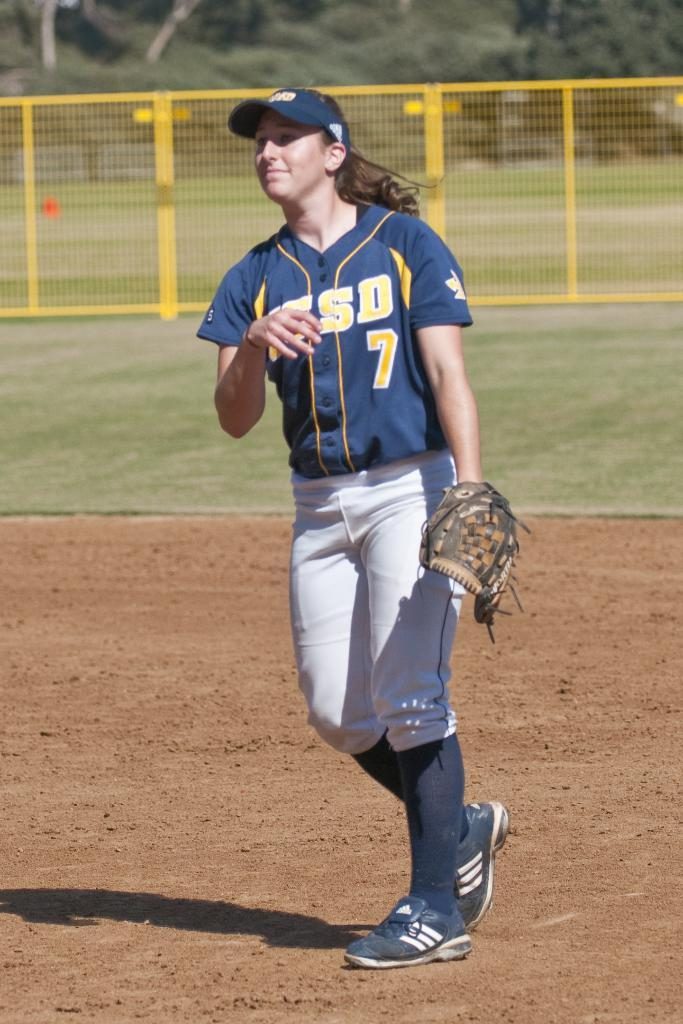<image>
Give a short and clear explanation of the subsequent image. A softball player wearing number 7 walks across the field. 